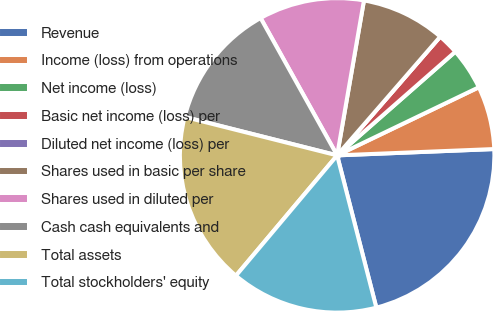<chart> <loc_0><loc_0><loc_500><loc_500><pie_chart><fcel>Revenue<fcel>Income (loss) from operations<fcel>Net income (loss)<fcel>Basic net income (loss) per<fcel>Diluted net income (loss) per<fcel>Shares used in basic per share<fcel>Shares used in diluted per<fcel>Cash cash equivalents and<fcel>Total assets<fcel>Total stockholders' equity<nl><fcel>21.63%<fcel>6.49%<fcel>4.33%<fcel>2.16%<fcel>0.0%<fcel>8.65%<fcel>10.82%<fcel>12.98%<fcel>17.8%<fcel>15.14%<nl></chart> 